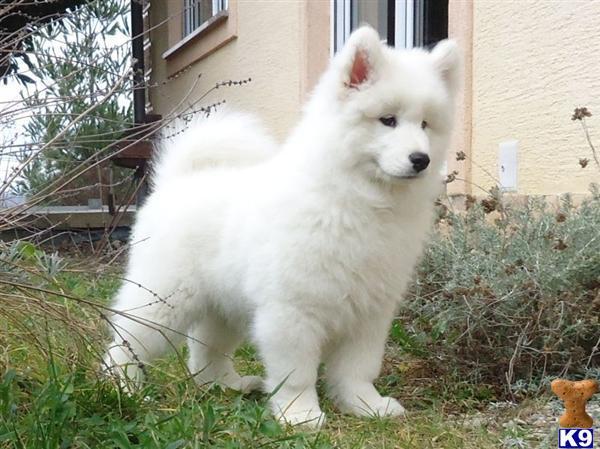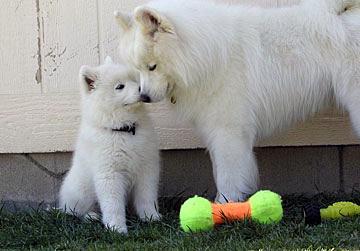The first image is the image on the left, the second image is the image on the right. Examine the images to the left and right. Is the description "The right image contains at least three white dogs." accurate? Answer yes or no. No. The first image is the image on the left, the second image is the image on the right. For the images shown, is this caption "An image features one white dog sleeping near one stuffed animal toy." true? Answer yes or no. No. 